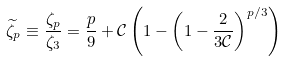<formula> <loc_0><loc_0><loc_500><loc_500>\widetilde { \zeta } _ { p } \equiv \frac { \zeta _ { p } } { \zeta _ { 3 } } = \frac { p } { 9 } + \mathcal { C } \left ( 1 - \left ( 1 - \frac { 2 } { 3 \mathcal { C } } \right ) ^ { p / 3 } \right )</formula> 